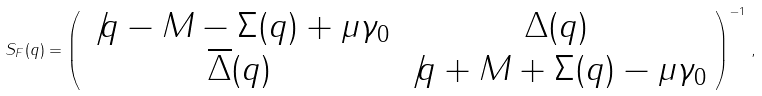Convert formula to latex. <formula><loc_0><loc_0><loc_500><loc_500>S _ { F } ( q ) = \left ( \begin{array} { c c } \not { q } - M - \Sigma ( q ) + \mu \gamma _ { 0 } & \Delta ( q ) \\ \overline { \Delta } ( q ) & \not { q } + M + \Sigma ( q ) - \mu \gamma _ { 0 } \end{array} \right ) ^ { - 1 } \, ,</formula> 